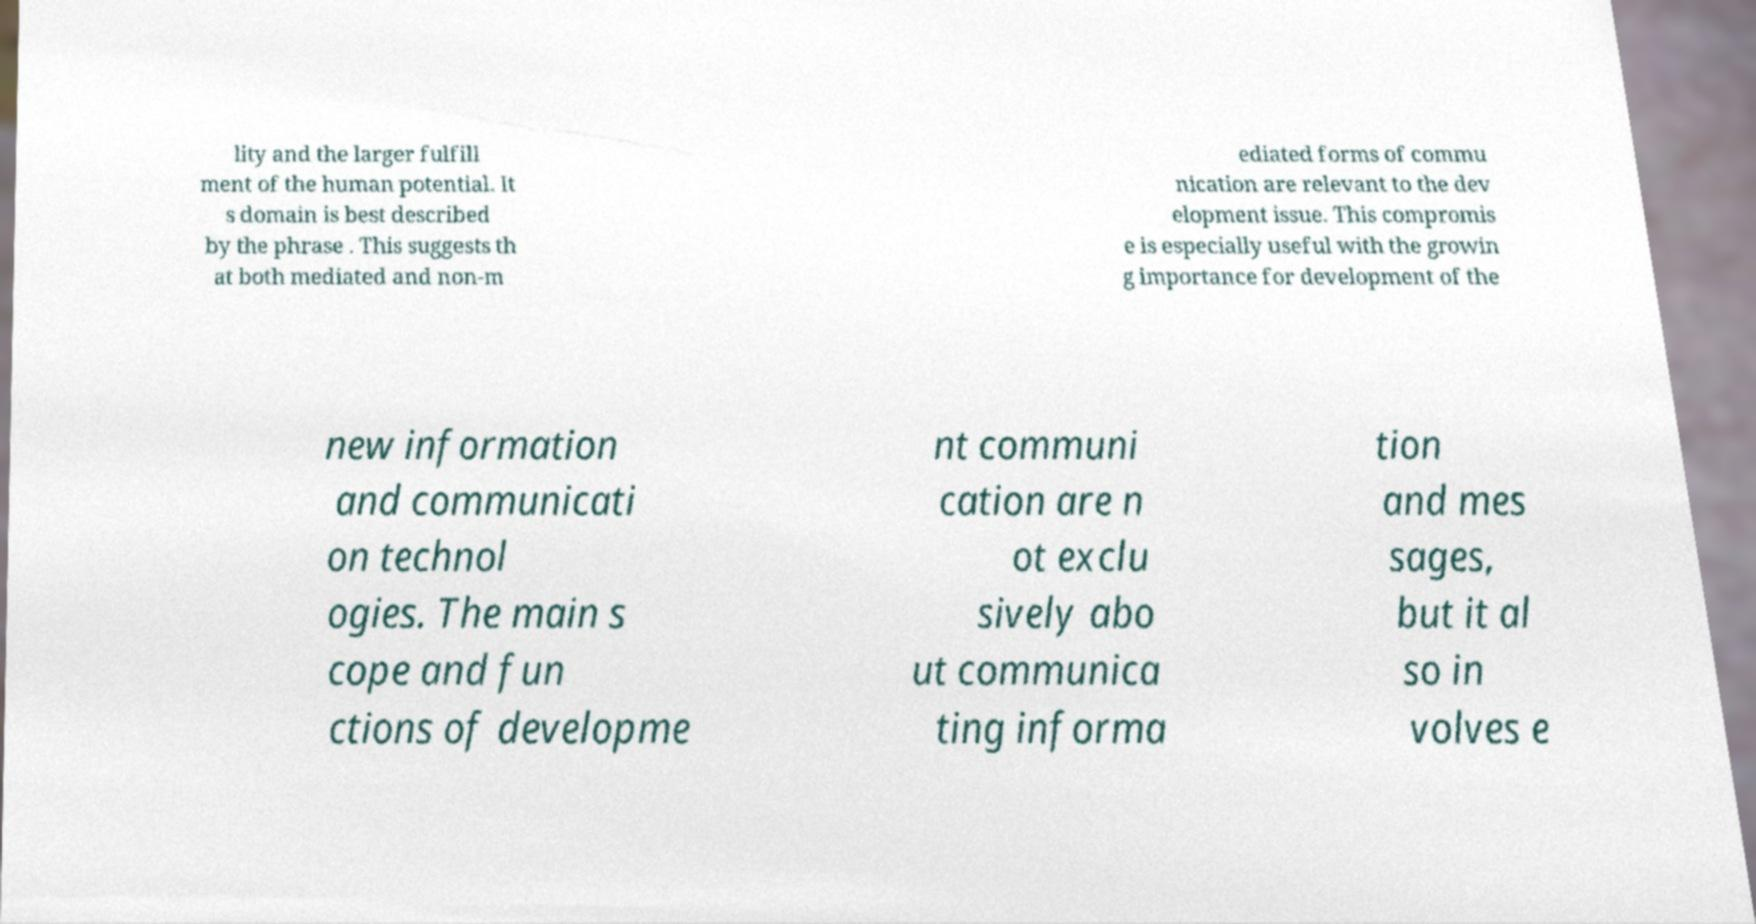Could you extract and type out the text from this image? lity and the larger fulfill ment of the human potential. It s domain is best described by the phrase . This suggests th at both mediated and non-m ediated forms of commu nication are relevant to the dev elopment issue. This compromis e is especially useful with the growin g importance for development of the new information and communicati on technol ogies. The main s cope and fun ctions of developme nt communi cation are n ot exclu sively abo ut communica ting informa tion and mes sages, but it al so in volves e 